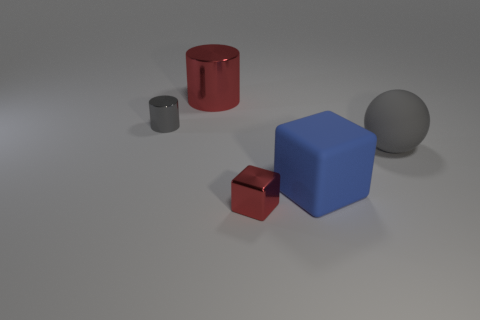What number of tiny things are either gray rubber balls or cyan cylinders?
Offer a terse response. 0. There is a metal cylinder to the left of the red cylinder; does it have the same size as the large blue cube?
Offer a very short reply. No. What number of other things are the same color as the sphere?
Offer a terse response. 1. What is the material of the blue block?
Give a very brief answer. Rubber. What is the object that is in front of the gray matte object and to the left of the big matte block made of?
Offer a terse response. Metal. What number of things are things that are on the left side of the small red object or large rubber cubes?
Keep it short and to the point. 3. Is the color of the metallic cube the same as the rubber block?
Give a very brief answer. No. Is there another block of the same size as the blue block?
Make the answer very short. No. What number of small metal objects are both behind the large matte block and on the right side of the tiny metal cylinder?
Give a very brief answer. 0. What number of small metallic objects are in front of the large blue block?
Make the answer very short. 1. 